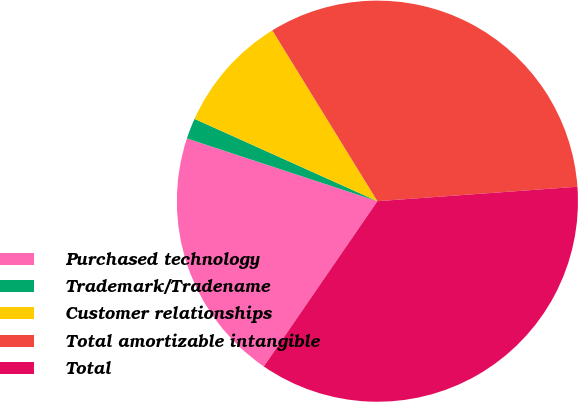Convert chart. <chart><loc_0><loc_0><loc_500><loc_500><pie_chart><fcel>Purchased technology<fcel>Trademark/Tradename<fcel>Customer relationships<fcel>Total amortizable intangible<fcel>Total<nl><fcel>20.48%<fcel>1.67%<fcel>9.49%<fcel>32.63%<fcel>35.73%<nl></chart> 